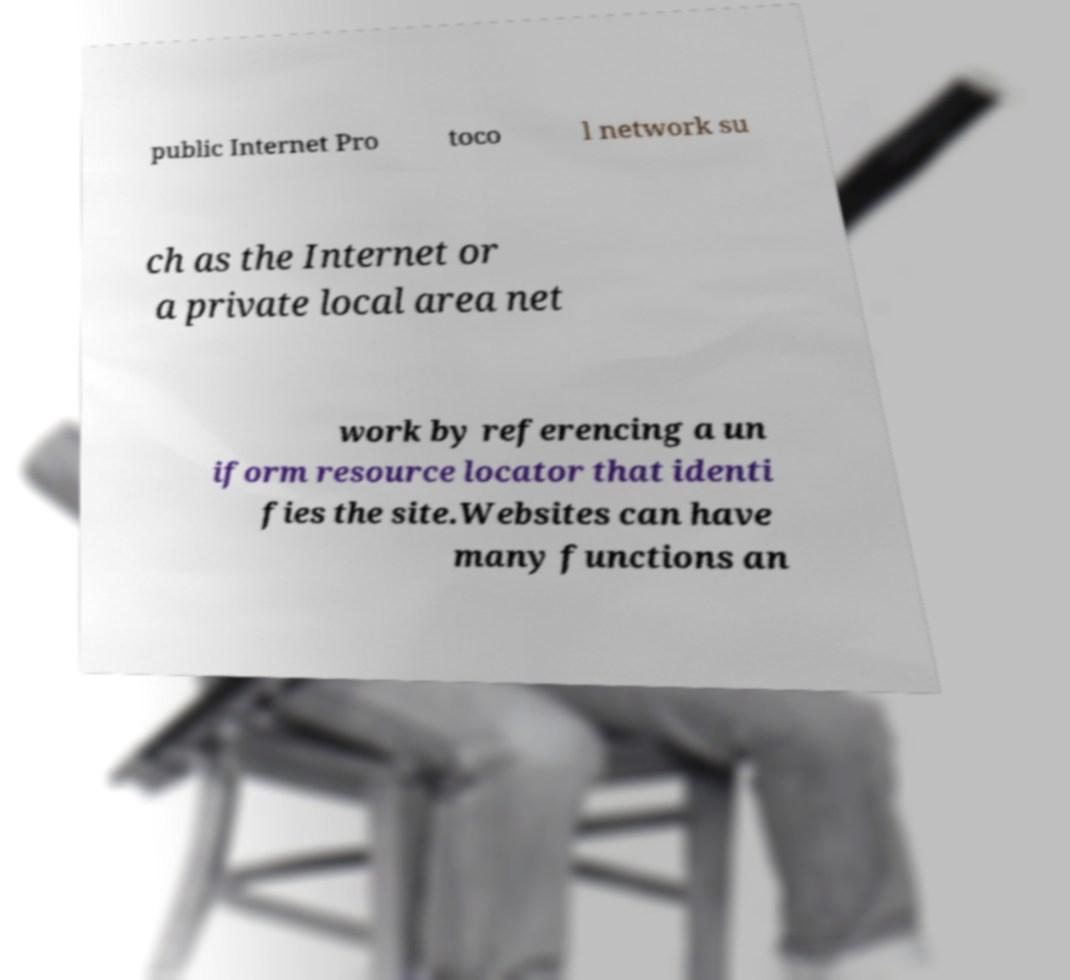There's text embedded in this image that I need extracted. Can you transcribe it verbatim? public Internet Pro toco l network su ch as the Internet or a private local area net work by referencing a un iform resource locator that identi fies the site.Websites can have many functions an 